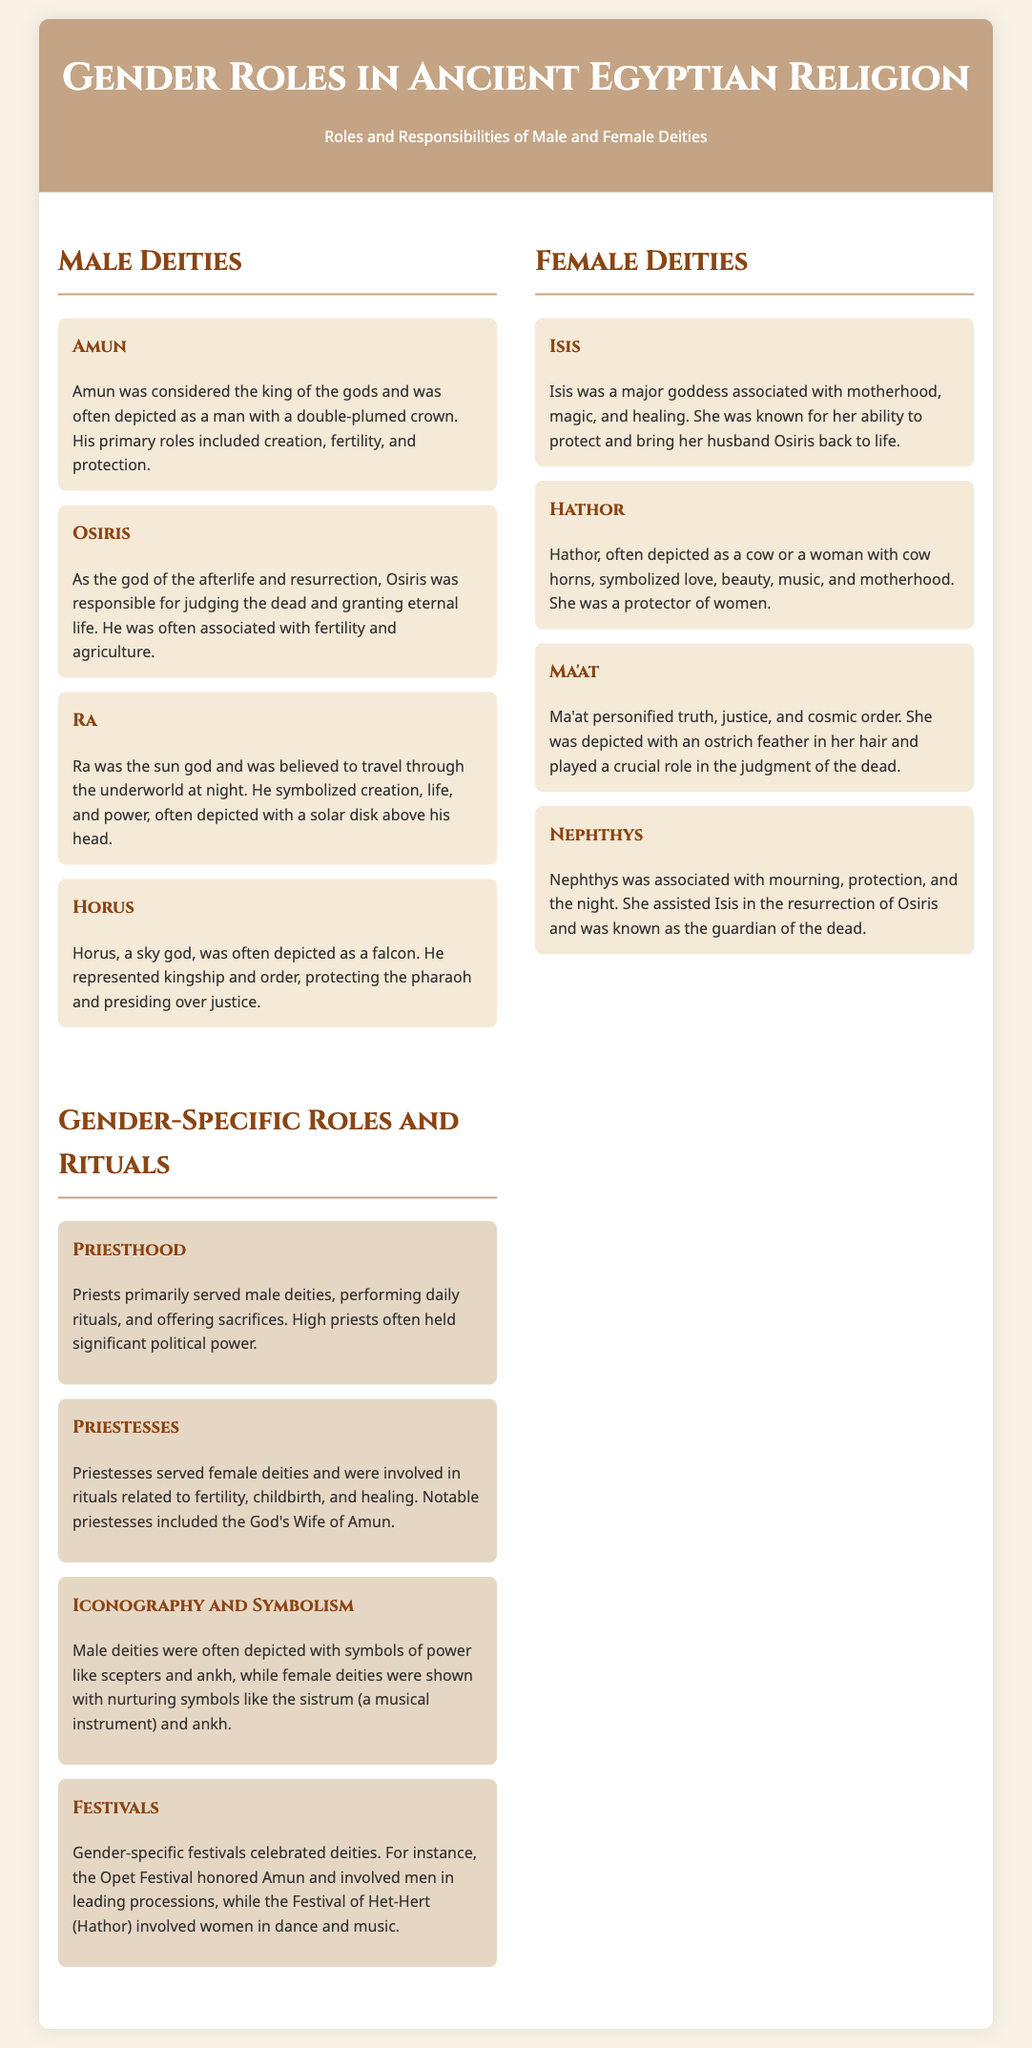What title is given to the list? The title given to the list is the main heading at the top of the document.
Answer: Gender Roles in Ancient Egyptian Religion Who is considered the king of the gods? The document specifically identifies Amun as the king of the gods.
Answer: Amun What aspect of Osiris is highlighted? The document states that Osiris is responsible for judging the dead and granting eternal life.
Answer: Afterlife and resurrection Which male deity is depicted as a falcon? The text describes Horus being depicted as a falcon.
Answer: Horus What is the primary role of priestesses? According to the document, priestesses were involved in rituals related to fertility, childbirth, and healing.
Answer: Fertility, childbirth, and healing What musical instrument is associated with female deities? The document mentions the sistrum as a symbol associated with female deities.
Answer: Sistrum Which festival involves women in dance and music? The document identifies the Festival of Het-Hert (Hathor) as one involving women in dance and music.
Answer: Festival of Het-Hert What does Ma'at represent? The document states that Ma'at personified truth, justice, and cosmic order.
Answer: Truth, justice, and cosmic order What do male deities often carry as symbols of power? The document explains that male deities are depicted with symbols like scepters and ankh.
Answer: Scepters and ankh 